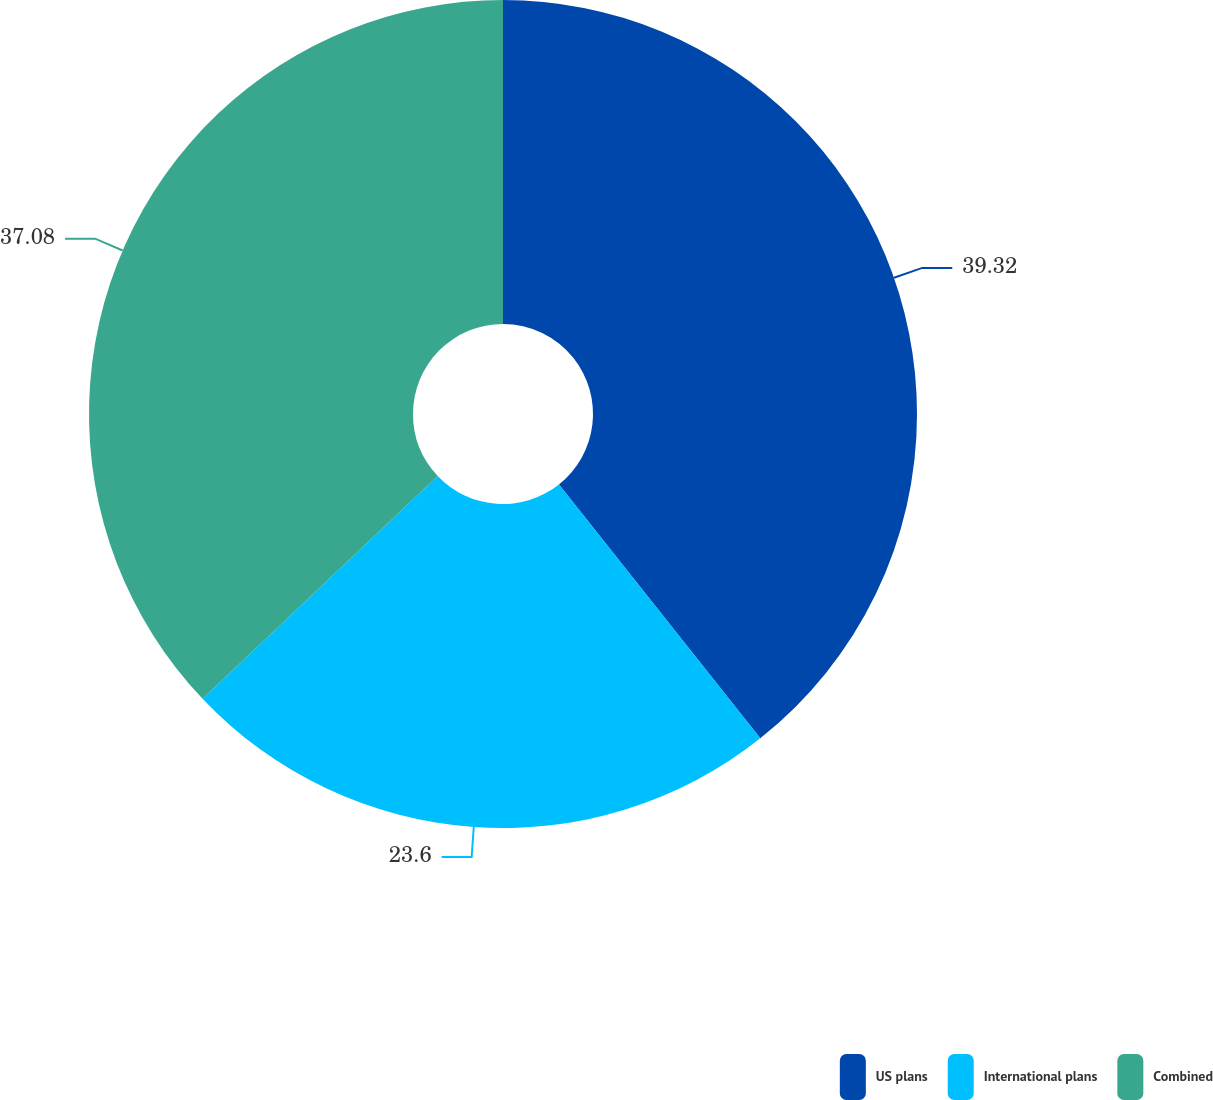Convert chart to OTSL. <chart><loc_0><loc_0><loc_500><loc_500><pie_chart><fcel>US plans<fcel>International plans<fcel>Combined<nl><fcel>39.33%<fcel>23.6%<fcel>37.08%<nl></chart> 